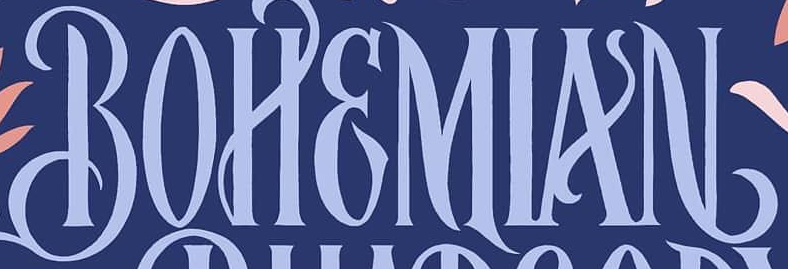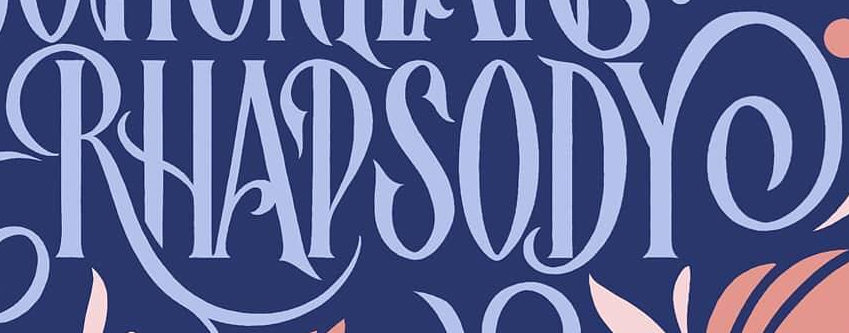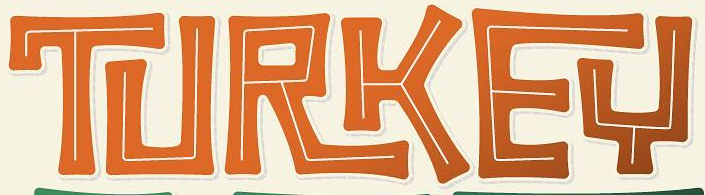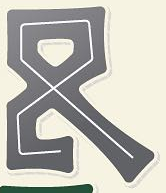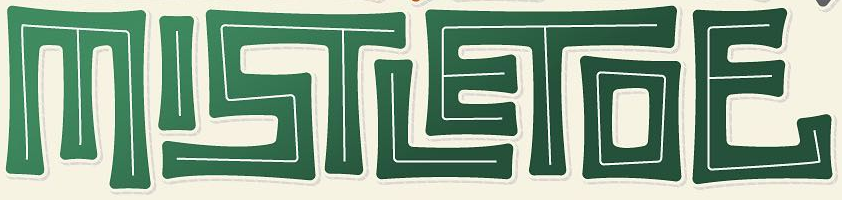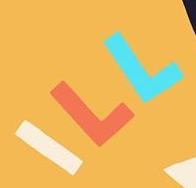Transcribe the words shown in these images in order, separated by a semicolon. BOHEMIAN; RHAPSODY; TURKEY; &; MISTLETOE; ILL 